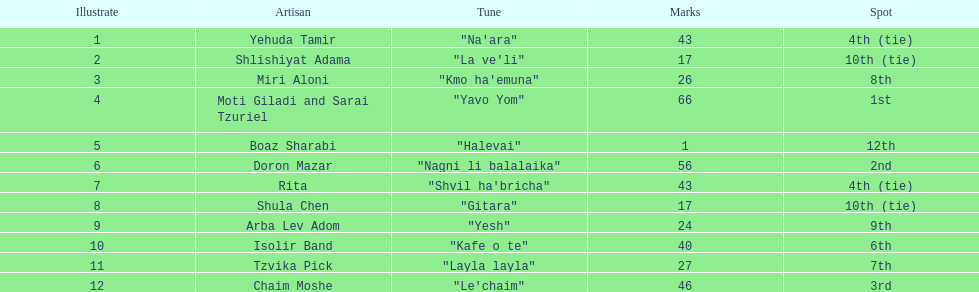What is the name of the song listed before the song "yesh"? "Gitara". 